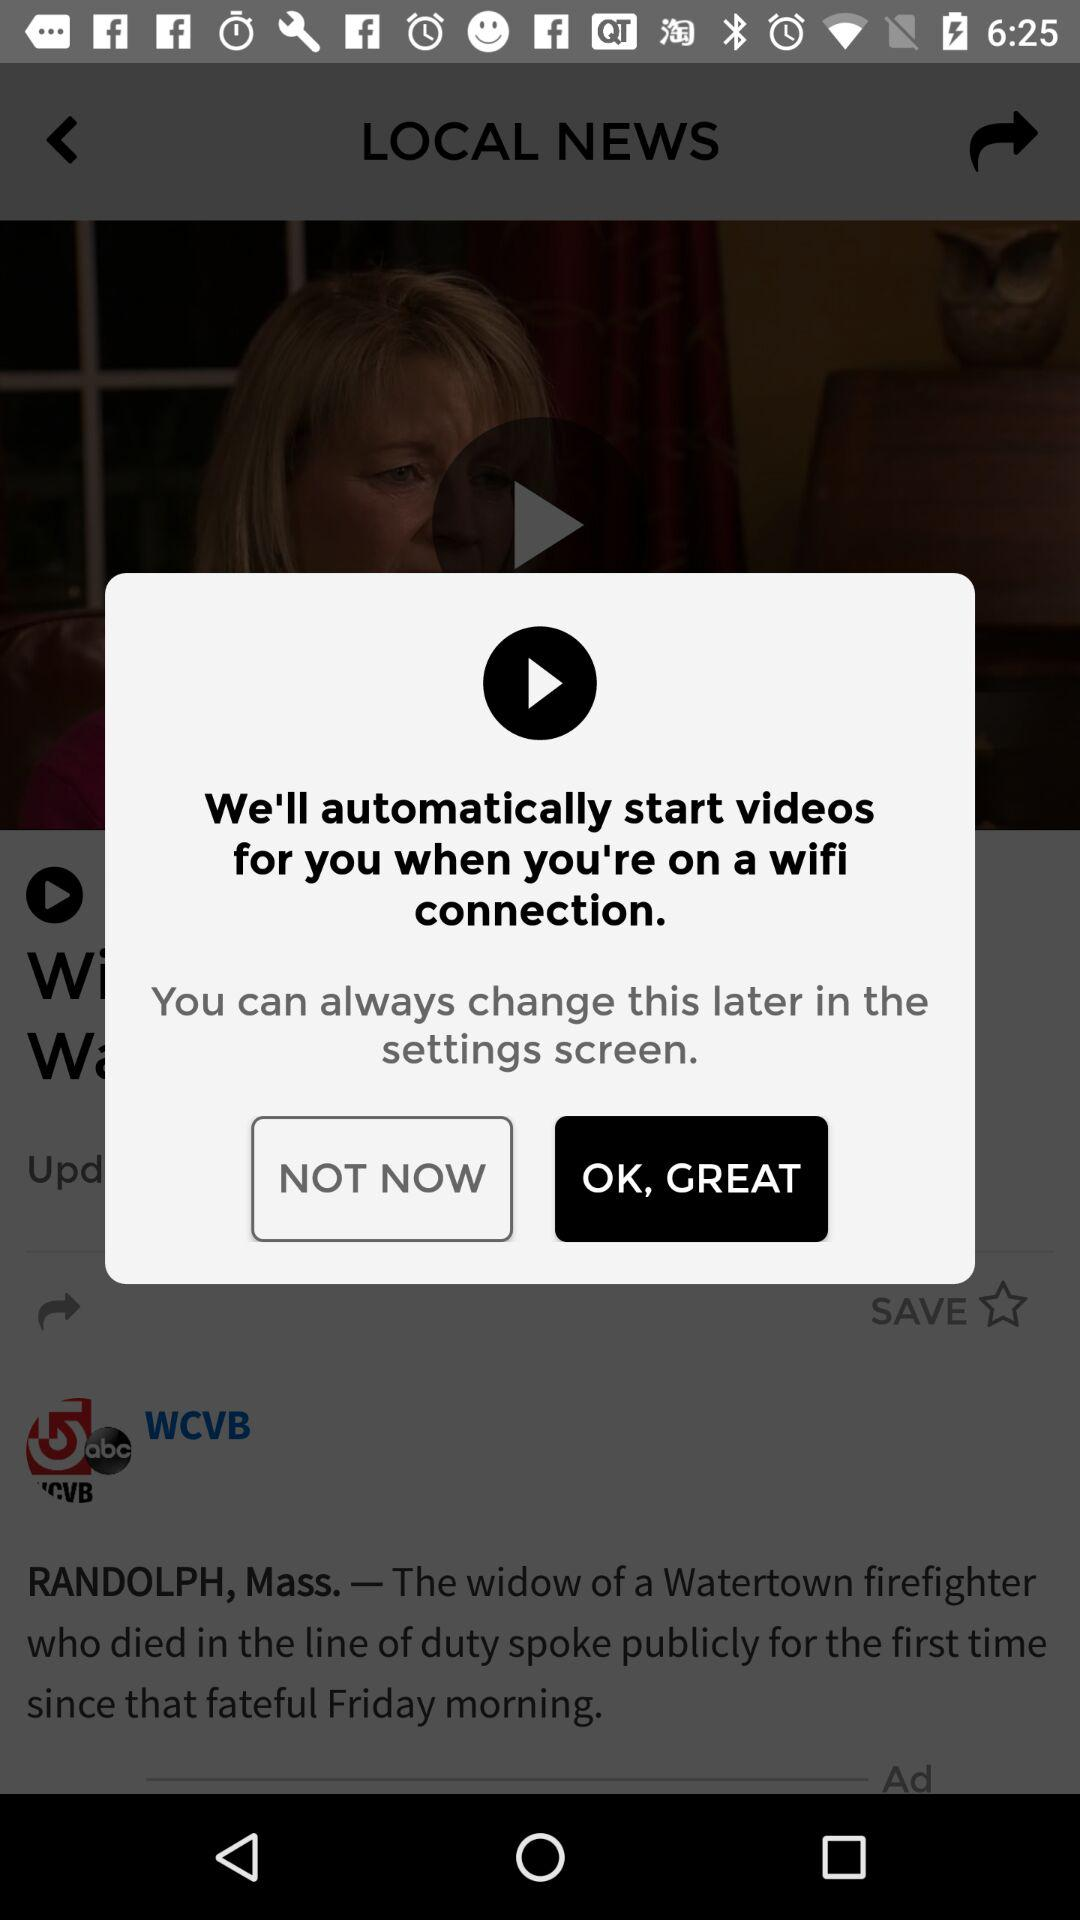Will it be cold and rainy tomorrow?
When the provided information is insufficient, respond with <no answer>. <no answer> 